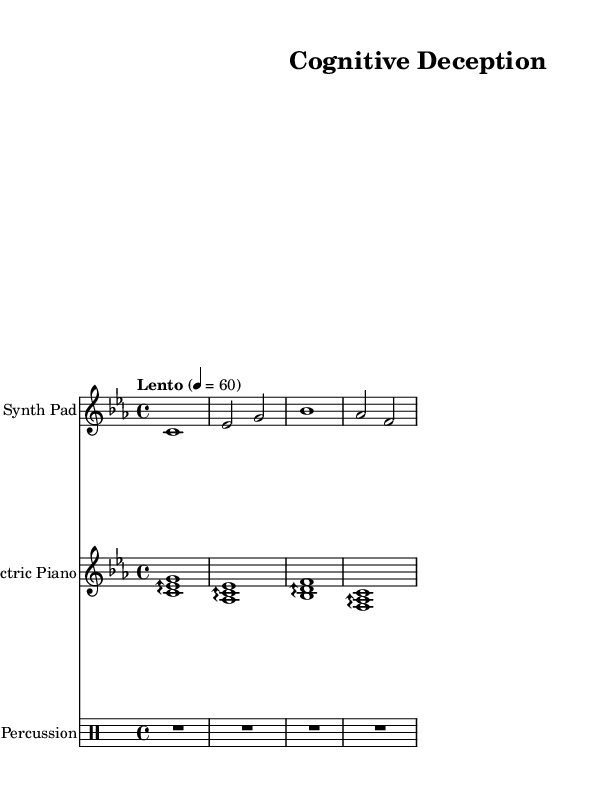What is the key signature of this music? The key signature is C minor, indicated by the presence of three flats (B flat, E flat, and A flat) in the staff.
Answer: C minor What is the time signature of this piece? The time signature is shown as 4/4, which means there are four beats per measure and a quarter note receives one beat.
Answer: 4/4 What is the tempo marking of this music? The tempo marking is indicated as "Lento," which suggests a slow pace for the performance, typically around 40 to 60 beats per minute.
Answer: Lento How many different instruments are present in this sheet music? There are three different instruments indicated: Synth Pad, Electric Piano, and Percussion, as seen in their respective staff names.
Answer: 3 What type of musical texture is predominantly featured in this composition? The composition features a layered texture with a harmonious blend of synth pad chords, electric piano arpeggios, and percussion, creating a rich ambient soundscape typical of cerebral music.
Answer: Layered What is the rhythmic value of the first note in the synth pad section? The first note in the synth pad section is a whole note (c1), which is held for the entire measure, making it the longest rhythmic value in that context.
Answer: Whole note In what musical style can this piece be classified? This piece can be classified as ambient music, as it utilizes synthesized sounds and atmospheric qualities to create a background conducive for deep focus and mental analysis.
Answer: Ambient 